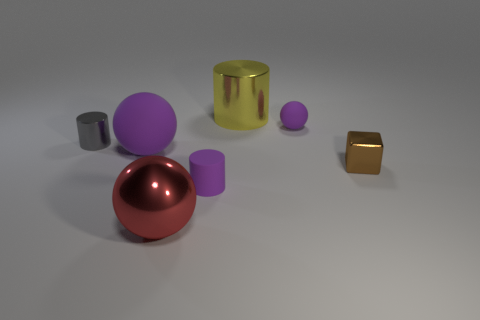Add 3 big cyan spheres. How many objects exist? 10 Subtract all spheres. How many objects are left? 4 Add 5 large yellow things. How many large yellow things are left? 6 Add 3 tiny purple matte spheres. How many tiny purple matte spheres exist? 4 Subtract 0 green cylinders. How many objects are left? 7 Subtract all big cylinders. Subtract all big metal spheres. How many objects are left? 5 